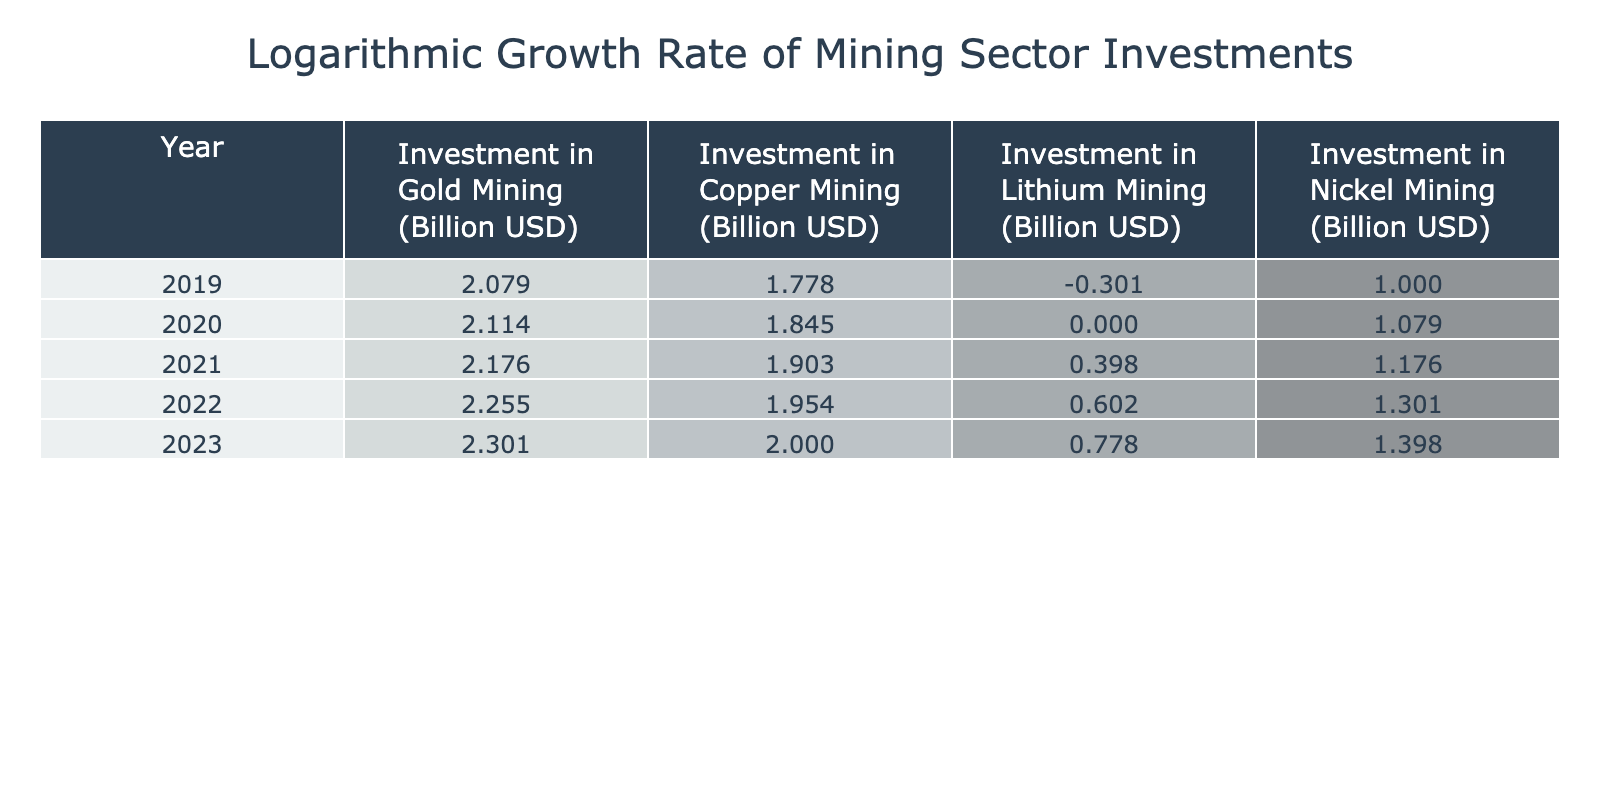What is the logarithmic investment in Gold Mining for the year 2022? In the table, the investment in Gold Mining for 2022 is listed as 180 billion USD. The logarithmic value of this investment is calculated using log base 10, which gives approximately 2.255.
Answer: 2.255 What was the investment in Copper Mining in 2020? The investment in Copper Mining for 2020 is directly stated in the table as 70 billion USD. Applying the logarithmic calculation gives us log(70), which is approximately 1.845.
Answer: 1.845 Which year saw the highest logarithmic investment in Lithium Mining? By reviewing the logarithmic values in the Lithium Mining column, we see that the value for 2023 is the highest at log(6.0), which is approximately 0.778. The other values for earlier years are progressively smaller.
Answer: 2023 What was the average logarithmic investment across all mining sectors for the year 2021? To find the average, we take the logarithmic values for all sectors in 2021: log(150) for Gold, log(80) for Copper, log(2.5) for Lithium, and log(15) for Nickel. Calculating these gives approximately 2.176, 1.903, 0.398, and 1.176. The average is then (2.176 + 1.903 + 0.398 + 1.176) / 4, which equals approximately 1.413.
Answer: 1.413 Is the investment in Nickel Mining higher in 2023 compared to 2022? The investments in Nickel Mining are 25 billion USD in 2023 (log(25) = approximately 1.398) and 20 billion USD in 2022 (log(20) = approximately 1.301). Since 1.398 > 1.301, the answer is yes.
Answer: Yes What is the difference in logarithmic values for Copper Mining between 2022 and 2019? The logarithmic value for Copper Mining in 2022 is log(90) which is approximately 1.954, and for 2019 it is log(60) which is approximately 1.778. The difference is 1.954 - 1.778 = 0.176.
Answer: 0.176 What was the total logarithmic investment in all mining sectors for the year 2023? To find the total, add up the logarithmic investments for each sector in 2023: log(200) for Gold, log(100) for Copper, log(6.0) for Lithium, log(25) for Nickel, which are approximately 2.301, 2.000, 0.778, and 1.398 respectively. Totaling these gives 2.301 + 2.000 + 0.778 + 1.398 = approximately 6.477.
Answer: 6.477 Was the investment in Zinc Mining ever recorded in this table? The table only details investments in Gold, Copper, Lithium, and Nickel Mining, with no mention of Zinc Mining. Thus, the answer is no.
Answer: No 